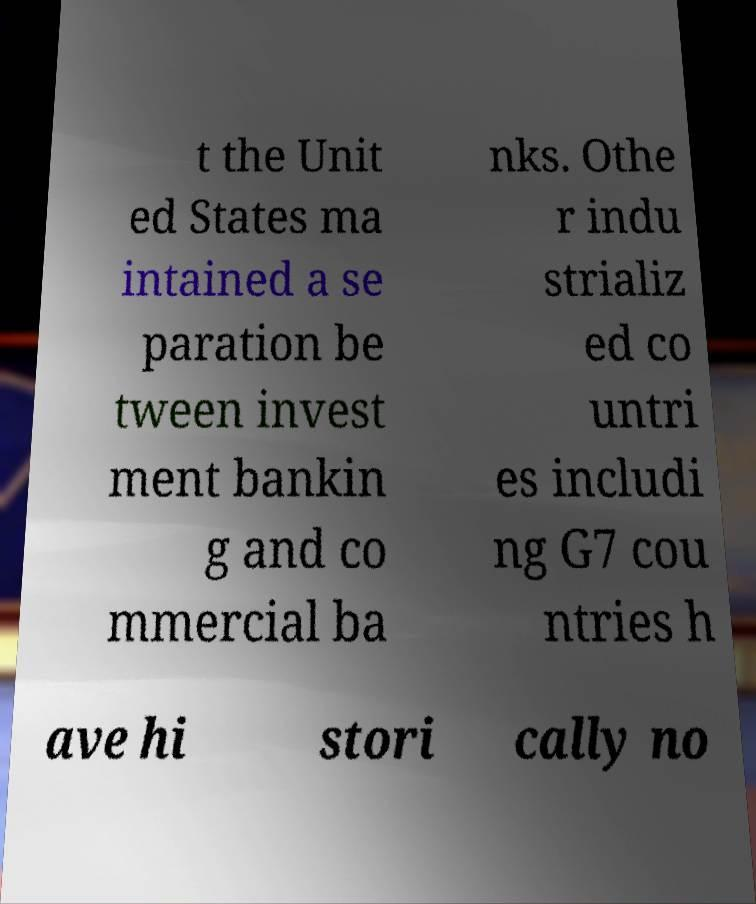Can you accurately transcribe the text from the provided image for me? t the Unit ed States ma intained a se paration be tween invest ment bankin g and co mmercial ba nks. Othe r indu strializ ed co untri es includi ng G7 cou ntries h ave hi stori cally no 